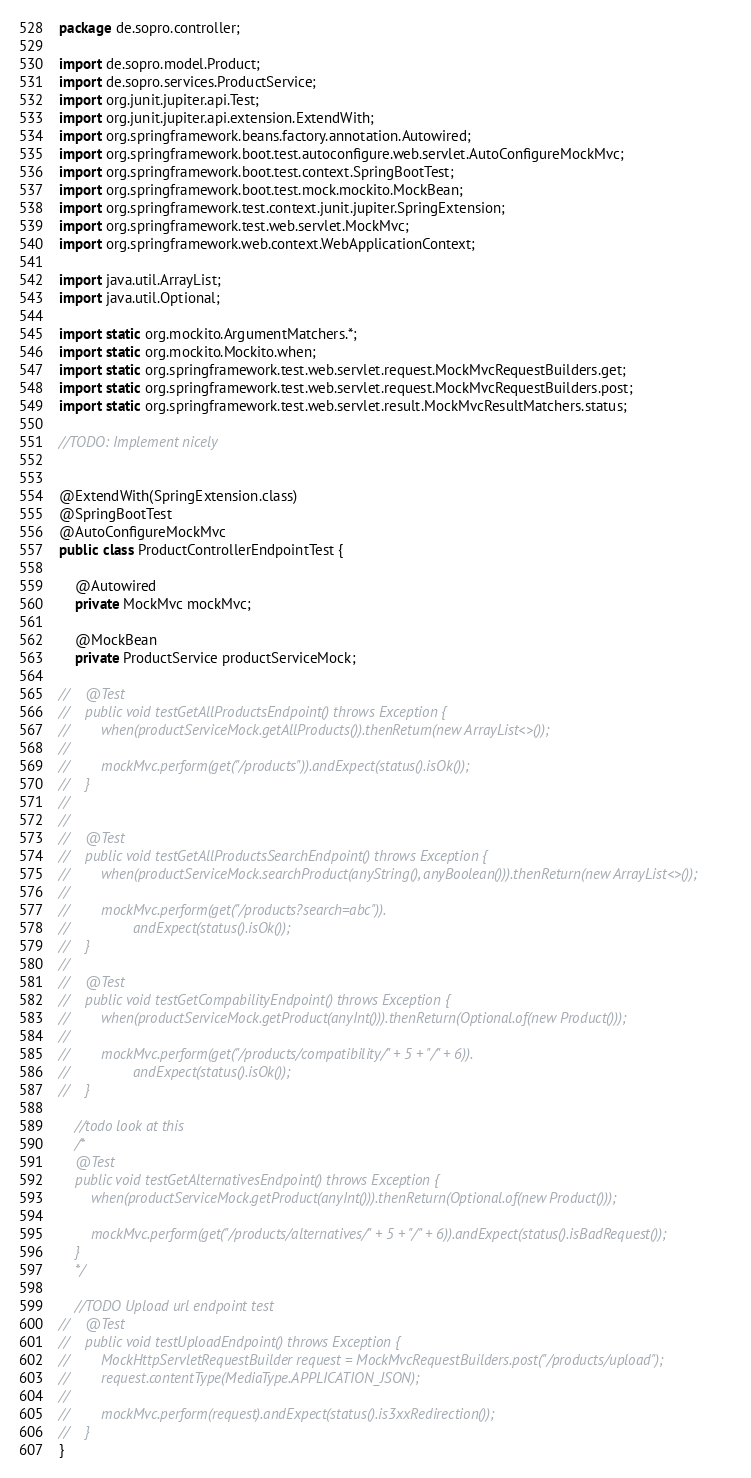<code> <loc_0><loc_0><loc_500><loc_500><_Java_>package de.sopro.controller;

import de.sopro.model.Product;
import de.sopro.services.ProductService;
import org.junit.jupiter.api.Test;
import org.junit.jupiter.api.extension.ExtendWith;
import org.springframework.beans.factory.annotation.Autowired;
import org.springframework.boot.test.autoconfigure.web.servlet.AutoConfigureMockMvc;
import org.springframework.boot.test.context.SpringBootTest;
import org.springframework.boot.test.mock.mockito.MockBean;
import org.springframework.test.context.junit.jupiter.SpringExtension;
import org.springframework.test.web.servlet.MockMvc;
import org.springframework.web.context.WebApplicationContext;

import java.util.ArrayList;
import java.util.Optional;

import static org.mockito.ArgumentMatchers.*;
import static org.mockito.Mockito.when;
import static org.springframework.test.web.servlet.request.MockMvcRequestBuilders.get;
import static org.springframework.test.web.servlet.request.MockMvcRequestBuilders.post;
import static org.springframework.test.web.servlet.result.MockMvcResultMatchers.status;

//TODO: Implement nicely


@ExtendWith(SpringExtension.class)
@SpringBootTest
@AutoConfigureMockMvc
public class ProductControllerEndpointTest {

    @Autowired
    private MockMvc mockMvc;

    @MockBean
    private ProductService productServiceMock;

//    @Test
//    public void testGetAllProductsEndpoint() throws Exception {
//        when(productServiceMock.getAllProducts()).thenReturn(new ArrayList<>());
//
//        mockMvc.perform(get("/products")).andExpect(status().isOk());
//    }
//
//
//    @Test
//    public void testGetAllProductsSearchEndpoint() throws Exception {
//        when(productServiceMock.searchProduct(anyString(), anyBoolean())).thenReturn(new ArrayList<>());
//
//        mockMvc.perform(get("/products?search=abc")).
//                andExpect(status().isOk());
//    }
//
//    @Test
//    public void testGetCompabilityEndpoint() throws Exception {
//        when(productServiceMock.getProduct(anyInt())).thenReturn(Optional.of(new Product()));
//
//        mockMvc.perform(get("/products/compatibility/" + 5 + "/" + 6)).
//                andExpect(status().isOk());
//    }

    //todo look at this
    /*
    @Test
    public void testGetAlternativesEndpoint() throws Exception {
        when(productServiceMock.getProduct(anyInt())).thenReturn(Optional.of(new Product()));

        mockMvc.perform(get("/products/alternatives/" + 5 + "/" + 6)).andExpect(status().isBadRequest());
    }
    */

    //TODO Upload url endpoint test
//    @Test
//    public void testUploadEndpoint() throws Exception {
//        MockHttpServletRequestBuilder request = MockMvcRequestBuilders.post("/products/upload");
//        request.contentType(MediaType.APPLICATION_JSON);
//
//        mockMvc.perform(request).andExpect(status().is3xxRedirection());
//    }
}</code> 